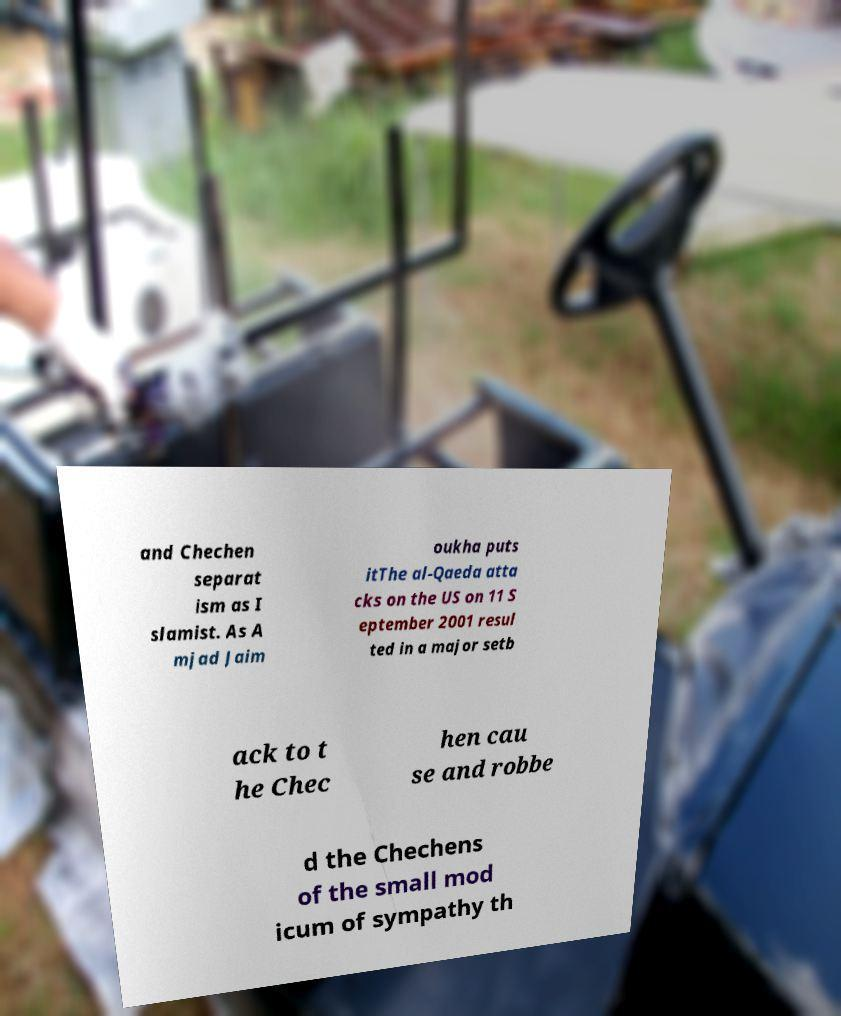Could you assist in decoding the text presented in this image and type it out clearly? and Chechen separat ism as I slamist. As A mjad Jaim oukha puts itThe al-Qaeda atta cks on the US on 11 S eptember 2001 resul ted in a major setb ack to t he Chec hen cau se and robbe d the Chechens of the small mod icum of sympathy th 